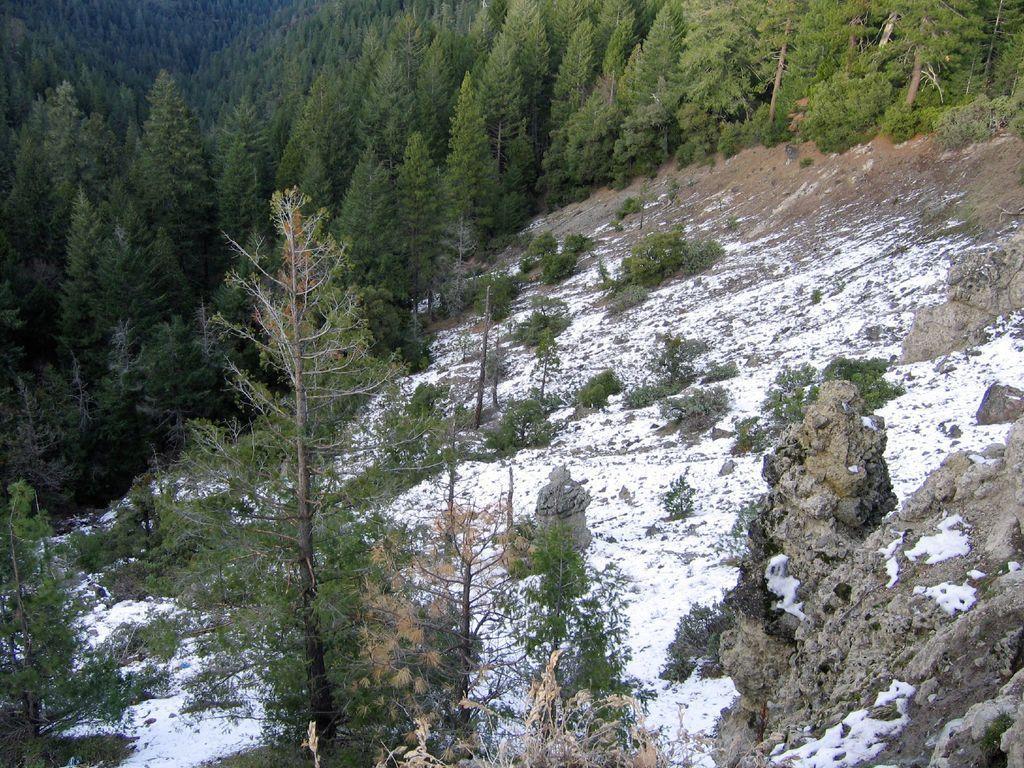Could you give a brief overview of what you see in this image? There are rocks, snow, and trees around the area of the image. 